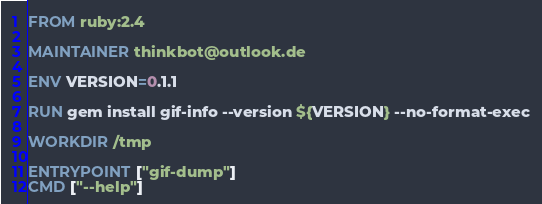Convert code to text. <code><loc_0><loc_0><loc_500><loc_500><_Dockerfile_>FROM ruby:2.4

MAINTAINER thinkbot@outlook.de

ENV VERSION=0.1.1

RUN gem install gif-info --version ${VERSION} --no-format-exec

WORKDIR /tmp

ENTRYPOINT ["gif-dump"]
CMD ["--help"]
</code> 